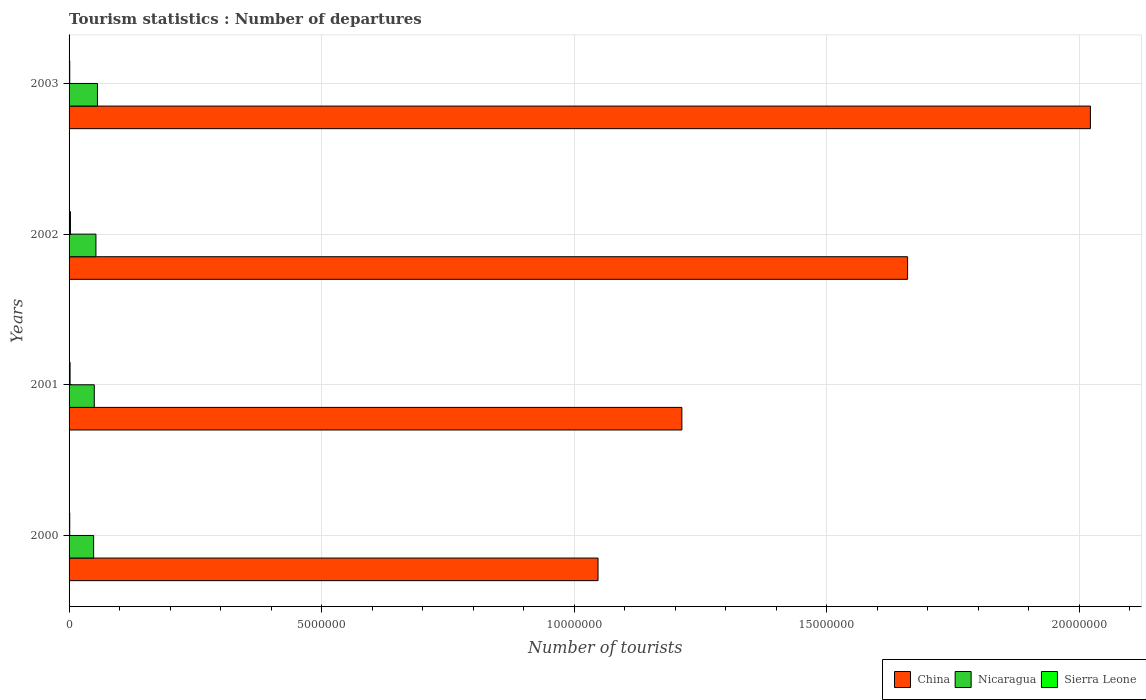How many different coloured bars are there?
Your response must be concise. 3. How many groups of bars are there?
Provide a short and direct response. 4. Are the number of bars on each tick of the Y-axis equal?
Give a very brief answer. Yes. How many bars are there on the 1st tick from the bottom?
Provide a short and direct response. 3. What is the label of the 4th group of bars from the top?
Offer a very short reply. 2000. What is the number of tourist departures in Sierra Leone in 2002?
Provide a short and direct response. 2.70e+04. Across all years, what is the maximum number of tourist departures in Nicaragua?
Provide a succinct answer. 5.62e+05. Across all years, what is the minimum number of tourist departures in Nicaragua?
Your answer should be very brief. 4.86e+05. In which year was the number of tourist departures in Sierra Leone maximum?
Ensure brevity in your answer.  2002. What is the total number of tourist departures in China in the graph?
Your answer should be compact. 5.94e+07. What is the difference between the number of tourist departures in Nicaragua in 2000 and that in 2003?
Offer a very short reply. -7.60e+04. What is the difference between the number of tourist departures in China in 2000 and the number of tourist departures in Sierra Leone in 2003?
Provide a succinct answer. 1.05e+07. What is the average number of tourist departures in Nicaragua per year?
Your answer should be very brief. 5.20e+05. In the year 2003, what is the difference between the number of tourist departures in Nicaragua and number of tourist departures in Sierra Leone?
Give a very brief answer. 5.49e+05. What is the ratio of the number of tourist departures in Nicaragua in 2001 to that in 2003?
Give a very brief answer. 0.89. Is the number of tourist departures in China in 2000 less than that in 2002?
Ensure brevity in your answer.  Yes. What is the difference between the highest and the second highest number of tourist departures in China?
Make the answer very short. 3.62e+06. What is the difference between the highest and the lowest number of tourist departures in China?
Make the answer very short. 9.75e+06. What does the 1st bar from the top in 2003 represents?
Keep it short and to the point. Sierra Leone. What does the 2nd bar from the bottom in 2002 represents?
Offer a very short reply. Nicaragua. Is it the case that in every year, the sum of the number of tourist departures in Nicaragua and number of tourist departures in Sierra Leone is greater than the number of tourist departures in China?
Your answer should be very brief. No. How many bars are there?
Your answer should be very brief. 12. Are the values on the major ticks of X-axis written in scientific E-notation?
Ensure brevity in your answer.  No. How many legend labels are there?
Your response must be concise. 3. How are the legend labels stacked?
Provide a succinct answer. Horizontal. What is the title of the graph?
Make the answer very short. Tourism statistics : Number of departures. What is the label or title of the X-axis?
Make the answer very short. Number of tourists. What is the label or title of the Y-axis?
Provide a succinct answer. Years. What is the Number of tourists of China in 2000?
Keep it short and to the point. 1.05e+07. What is the Number of tourists in Nicaragua in 2000?
Your response must be concise. 4.86e+05. What is the Number of tourists of Sierra Leone in 2000?
Offer a very short reply. 1.30e+04. What is the Number of tourists in China in 2001?
Keep it short and to the point. 1.21e+07. What is the Number of tourists of Nicaragua in 2001?
Your answer should be very brief. 4.99e+05. What is the Number of tourists of Sierra Leone in 2001?
Your response must be concise. 2.00e+04. What is the Number of tourists in China in 2002?
Your answer should be very brief. 1.66e+07. What is the Number of tourists in Nicaragua in 2002?
Your answer should be very brief. 5.32e+05. What is the Number of tourists in Sierra Leone in 2002?
Give a very brief answer. 2.70e+04. What is the Number of tourists of China in 2003?
Provide a short and direct response. 2.02e+07. What is the Number of tourists of Nicaragua in 2003?
Provide a short and direct response. 5.62e+05. What is the Number of tourists in Sierra Leone in 2003?
Your answer should be compact. 1.30e+04. Across all years, what is the maximum Number of tourists of China?
Your answer should be very brief. 2.02e+07. Across all years, what is the maximum Number of tourists of Nicaragua?
Offer a terse response. 5.62e+05. Across all years, what is the maximum Number of tourists in Sierra Leone?
Ensure brevity in your answer.  2.70e+04. Across all years, what is the minimum Number of tourists of China?
Offer a terse response. 1.05e+07. Across all years, what is the minimum Number of tourists in Nicaragua?
Your answer should be very brief. 4.86e+05. Across all years, what is the minimum Number of tourists in Sierra Leone?
Make the answer very short. 1.30e+04. What is the total Number of tourists in China in the graph?
Your answer should be very brief. 5.94e+07. What is the total Number of tourists in Nicaragua in the graph?
Ensure brevity in your answer.  2.08e+06. What is the total Number of tourists of Sierra Leone in the graph?
Make the answer very short. 7.30e+04. What is the difference between the Number of tourists of China in 2000 and that in 2001?
Your response must be concise. -1.66e+06. What is the difference between the Number of tourists in Nicaragua in 2000 and that in 2001?
Offer a terse response. -1.30e+04. What is the difference between the Number of tourists in Sierra Leone in 2000 and that in 2001?
Make the answer very short. -7000. What is the difference between the Number of tourists in China in 2000 and that in 2002?
Your response must be concise. -6.13e+06. What is the difference between the Number of tourists in Nicaragua in 2000 and that in 2002?
Make the answer very short. -4.60e+04. What is the difference between the Number of tourists of Sierra Leone in 2000 and that in 2002?
Make the answer very short. -1.40e+04. What is the difference between the Number of tourists of China in 2000 and that in 2003?
Provide a short and direct response. -9.75e+06. What is the difference between the Number of tourists of Nicaragua in 2000 and that in 2003?
Keep it short and to the point. -7.60e+04. What is the difference between the Number of tourists in Sierra Leone in 2000 and that in 2003?
Keep it short and to the point. 0. What is the difference between the Number of tourists in China in 2001 and that in 2002?
Your answer should be compact. -4.47e+06. What is the difference between the Number of tourists in Nicaragua in 2001 and that in 2002?
Keep it short and to the point. -3.30e+04. What is the difference between the Number of tourists of Sierra Leone in 2001 and that in 2002?
Your answer should be compact. -7000. What is the difference between the Number of tourists in China in 2001 and that in 2003?
Make the answer very short. -8.09e+06. What is the difference between the Number of tourists of Nicaragua in 2001 and that in 2003?
Provide a short and direct response. -6.30e+04. What is the difference between the Number of tourists in Sierra Leone in 2001 and that in 2003?
Provide a succinct answer. 7000. What is the difference between the Number of tourists in China in 2002 and that in 2003?
Your answer should be very brief. -3.62e+06. What is the difference between the Number of tourists of Nicaragua in 2002 and that in 2003?
Provide a succinct answer. -3.00e+04. What is the difference between the Number of tourists of Sierra Leone in 2002 and that in 2003?
Make the answer very short. 1.40e+04. What is the difference between the Number of tourists in China in 2000 and the Number of tourists in Nicaragua in 2001?
Your answer should be very brief. 9.97e+06. What is the difference between the Number of tourists in China in 2000 and the Number of tourists in Sierra Leone in 2001?
Ensure brevity in your answer.  1.05e+07. What is the difference between the Number of tourists in Nicaragua in 2000 and the Number of tourists in Sierra Leone in 2001?
Your response must be concise. 4.66e+05. What is the difference between the Number of tourists in China in 2000 and the Number of tourists in Nicaragua in 2002?
Your answer should be very brief. 9.94e+06. What is the difference between the Number of tourists of China in 2000 and the Number of tourists of Sierra Leone in 2002?
Your response must be concise. 1.04e+07. What is the difference between the Number of tourists of Nicaragua in 2000 and the Number of tourists of Sierra Leone in 2002?
Your response must be concise. 4.59e+05. What is the difference between the Number of tourists of China in 2000 and the Number of tourists of Nicaragua in 2003?
Give a very brief answer. 9.91e+06. What is the difference between the Number of tourists of China in 2000 and the Number of tourists of Sierra Leone in 2003?
Your answer should be compact. 1.05e+07. What is the difference between the Number of tourists of Nicaragua in 2000 and the Number of tourists of Sierra Leone in 2003?
Provide a succinct answer. 4.73e+05. What is the difference between the Number of tourists of China in 2001 and the Number of tourists of Nicaragua in 2002?
Provide a short and direct response. 1.16e+07. What is the difference between the Number of tourists of China in 2001 and the Number of tourists of Sierra Leone in 2002?
Provide a succinct answer. 1.21e+07. What is the difference between the Number of tourists in Nicaragua in 2001 and the Number of tourists in Sierra Leone in 2002?
Offer a terse response. 4.72e+05. What is the difference between the Number of tourists in China in 2001 and the Number of tourists in Nicaragua in 2003?
Your answer should be compact. 1.16e+07. What is the difference between the Number of tourists in China in 2001 and the Number of tourists in Sierra Leone in 2003?
Provide a short and direct response. 1.21e+07. What is the difference between the Number of tourists of Nicaragua in 2001 and the Number of tourists of Sierra Leone in 2003?
Give a very brief answer. 4.86e+05. What is the difference between the Number of tourists of China in 2002 and the Number of tourists of Nicaragua in 2003?
Give a very brief answer. 1.60e+07. What is the difference between the Number of tourists in China in 2002 and the Number of tourists in Sierra Leone in 2003?
Provide a short and direct response. 1.66e+07. What is the difference between the Number of tourists in Nicaragua in 2002 and the Number of tourists in Sierra Leone in 2003?
Make the answer very short. 5.19e+05. What is the average Number of tourists in China per year?
Your response must be concise. 1.49e+07. What is the average Number of tourists in Nicaragua per year?
Ensure brevity in your answer.  5.20e+05. What is the average Number of tourists of Sierra Leone per year?
Keep it short and to the point. 1.82e+04. In the year 2000, what is the difference between the Number of tourists of China and Number of tourists of Nicaragua?
Offer a very short reply. 9.99e+06. In the year 2000, what is the difference between the Number of tourists of China and Number of tourists of Sierra Leone?
Offer a terse response. 1.05e+07. In the year 2000, what is the difference between the Number of tourists in Nicaragua and Number of tourists in Sierra Leone?
Make the answer very short. 4.73e+05. In the year 2001, what is the difference between the Number of tourists in China and Number of tourists in Nicaragua?
Give a very brief answer. 1.16e+07. In the year 2001, what is the difference between the Number of tourists of China and Number of tourists of Sierra Leone?
Your answer should be compact. 1.21e+07. In the year 2001, what is the difference between the Number of tourists of Nicaragua and Number of tourists of Sierra Leone?
Give a very brief answer. 4.79e+05. In the year 2002, what is the difference between the Number of tourists in China and Number of tourists in Nicaragua?
Your answer should be very brief. 1.61e+07. In the year 2002, what is the difference between the Number of tourists in China and Number of tourists in Sierra Leone?
Your answer should be very brief. 1.66e+07. In the year 2002, what is the difference between the Number of tourists in Nicaragua and Number of tourists in Sierra Leone?
Give a very brief answer. 5.05e+05. In the year 2003, what is the difference between the Number of tourists in China and Number of tourists in Nicaragua?
Offer a terse response. 1.97e+07. In the year 2003, what is the difference between the Number of tourists in China and Number of tourists in Sierra Leone?
Ensure brevity in your answer.  2.02e+07. In the year 2003, what is the difference between the Number of tourists in Nicaragua and Number of tourists in Sierra Leone?
Offer a very short reply. 5.49e+05. What is the ratio of the Number of tourists of China in 2000 to that in 2001?
Keep it short and to the point. 0.86. What is the ratio of the Number of tourists of Nicaragua in 2000 to that in 2001?
Ensure brevity in your answer.  0.97. What is the ratio of the Number of tourists in Sierra Leone in 2000 to that in 2001?
Make the answer very short. 0.65. What is the ratio of the Number of tourists of China in 2000 to that in 2002?
Provide a succinct answer. 0.63. What is the ratio of the Number of tourists of Nicaragua in 2000 to that in 2002?
Give a very brief answer. 0.91. What is the ratio of the Number of tourists of Sierra Leone in 2000 to that in 2002?
Give a very brief answer. 0.48. What is the ratio of the Number of tourists of China in 2000 to that in 2003?
Provide a short and direct response. 0.52. What is the ratio of the Number of tourists in Nicaragua in 2000 to that in 2003?
Offer a terse response. 0.86. What is the ratio of the Number of tourists in Sierra Leone in 2000 to that in 2003?
Keep it short and to the point. 1. What is the ratio of the Number of tourists of China in 2001 to that in 2002?
Your answer should be very brief. 0.73. What is the ratio of the Number of tourists of Nicaragua in 2001 to that in 2002?
Provide a succinct answer. 0.94. What is the ratio of the Number of tourists in Sierra Leone in 2001 to that in 2002?
Offer a terse response. 0.74. What is the ratio of the Number of tourists of Nicaragua in 2001 to that in 2003?
Ensure brevity in your answer.  0.89. What is the ratio of the Number of tourists in Sierra Leone in 2001 to that in 2003?
Your response must be concise. 1.54. What is the ratio of the Number of tourists of China in 2002 to that in 2003?
Provide a succinct answer. 0.82. What is the ratio of the Number of tourists of Nicaragua in 2002 to that in 2003?
Your answer should be very brief. 0.95. What is the ratio of the Number of tourists in Sierra Leone in 2002 to that in 2003?
Ensure brevity in your answer.  2.08. What is the difference between the highest and the second highest Number of tourists of China?
Keep it short and to the point. 3.62e+06. What is the difference between the highest and the second highest Number of tourists of Nicaragua?
Provide a succinct answer. 3.00e+04. What is the difference between the highest and the second highest Number of tourists in Sierra Leone?
Give a very brief answer. 7000. What is the difference between the highest and the lowest Number of tourists in China?
Offer a terse response. 9.75e+06. What is the difference between the highest and the lowest Number of tourists of Nicaragua?
Your response must be concise. 7.60e+04. What is the difference between the highest and the lowest Number of tourists of Sierra Leone?
Provide a short and direct response. 1.40e+04. 